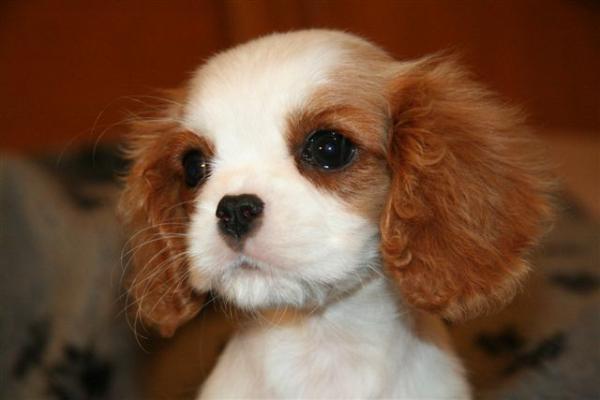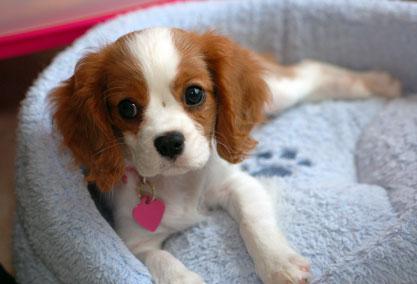The first image is the image on the left, the second image is the image on the right. Considering the images on both sides, is "One of the puppies is wearing a collar with pink heart." valid? Answer yes or no. Yes. The first image is the image on the left, the second image is the image on the right. Given the left and right images, does the statement "There are no more than two puppies." hold true? Answer yes or no. Yes. 